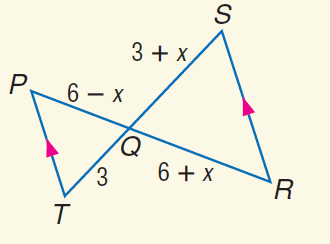Answer the mathemtical geometry problem and directly provide the correct option letter.
Question: Find Q S.
Choices: A: 3 B: 4 C: 6 D: 9 A 